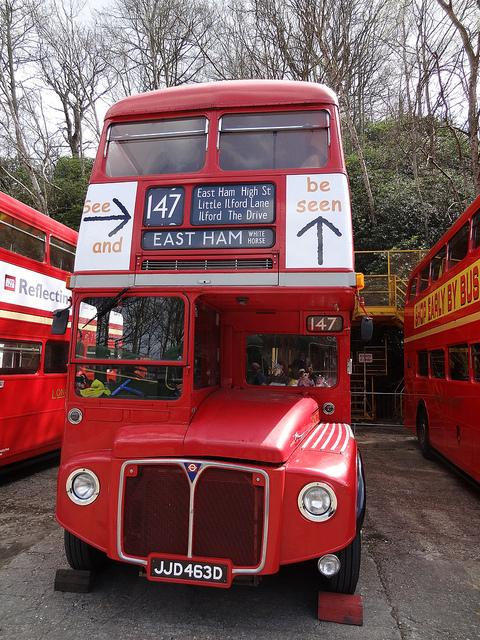What do the items in front of the tires here prevent?

Choices:
A) reversals
B) speeding
C) rolling
D) advertising rolling 